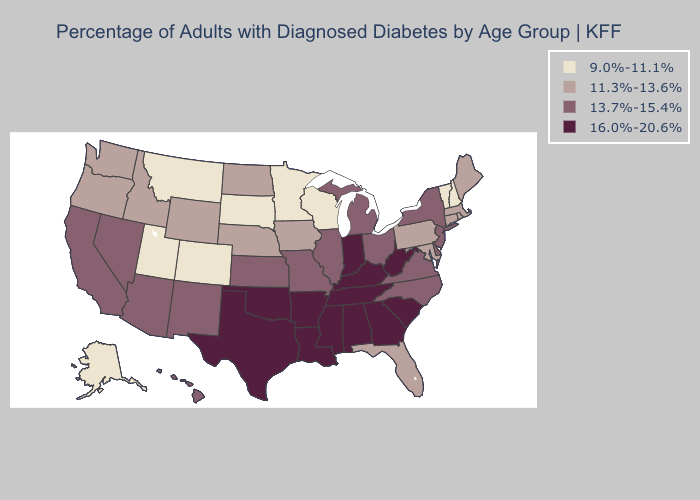What is the value of Montana?
Answer briefly. 9.0%-11.1%. Name the states that have a value in the range 9.0%-11.1%?
Give a very brief answer. Alaska, Colorado, Minnesota, Montana, New Hampshire, South Dakota, Utah, Vermont, Wisconsin. What is the highest value in the South ?
Short answer required. 16.0%-20.6%. Among the states that border Ohio , which have the highest value?
Be succinct. Indiana, Kentucky, West Virginia. Which states have the highest value in the USA?
Concise answer only. Alabama, Arkansas, Georgia, Indiana, Kentucky, Louisiana, Mississippi, Oklahoma, South Carolina, Tennessee, Texas, West Virginia. Does Kansas have a lower value than New Hampshire?
Keep it brief. No. What is the value of Mississippi?
Answer briefly. 16.0%-20.6%. What is the value of California?
Short answer required. 13.7%-15.4%. Name the states that have a value in the range 11.3%-13.6%?
Short answer required. Connecticut, Florida, Idaho, Iowa, Maine, Maryland, Massachusetts, Nebraska, North Dakota, Oregon, Pennsylvania, Rhode Island, Washington, Wyoming. Which states have the lowest value in the Northeast?
Short answer required. New Hampshire, Vermont. Name the states that have a value in the range 13.7%-15.4%?
Quick response, please. Arizona, California, Delaware, Hawaii, Illinois, Kansas, Michigan, Missouri, Nevada, New Jersey, New Mexico, New York, North Carolina, Ohio, Virginia. What is the highest value in the USA?
Write a very short answer. 16.0%-20.6%. What is the lowest value in the USA?
Answer briefly. 9.0%-11.1%. 